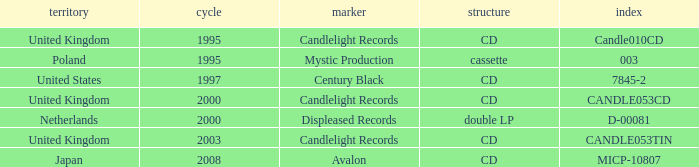What was the Candlelight Records Catalog of Candle053tin format? CD. 